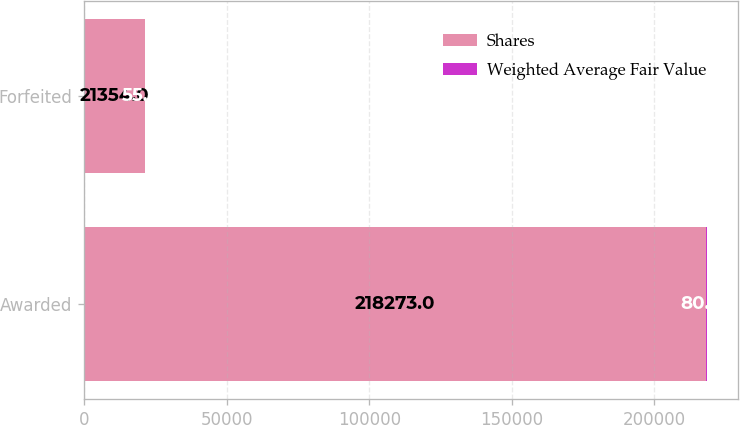Convert chart. <chart><loc_0><loc_0><loc_500><loc_500><stacked_bar_chart><ecel><fcel>Awarded<fcel>Forfeited<nl><fcel>Shares<fcel>218273<fcel>21354<nl><fcel>Weighted Average Fair Value<fcel>80.24<fcel>55.41<nl></chart> 